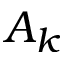<formula> <loc_0><loc_0><loc_500><loc_500>A _ { k }</formula> 